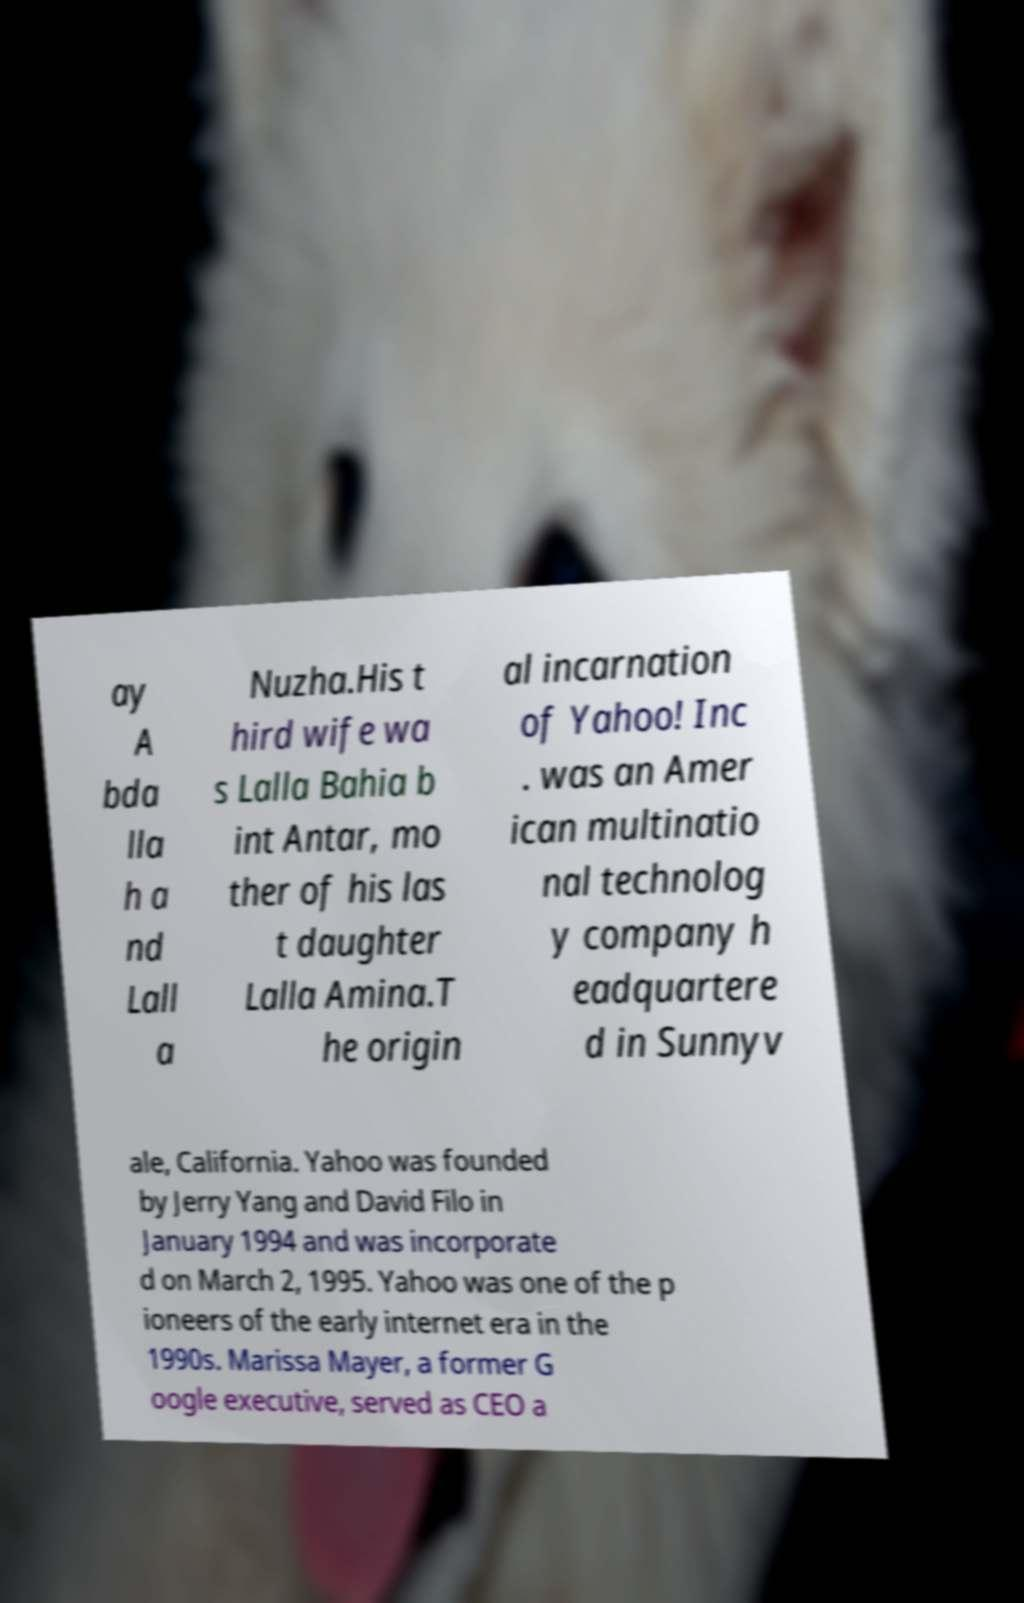Could you extract and type out the text from this image? ay A bda lla h a nd Lall a Nuzha.His t hird wife wa s Lalla Bahia b int Antar, mo ther of his las t daughter Lalla Amina.T he origin al incarnation of Yahoo! Inc . was an Amer ican multinatio nal technolog y company h eadquartere d in Sunnyv ale, California. Yahoo was founded by Jerry Yang and David Filo in January 1994 and was incorporate d on March 2, 1995. Yahoo was one of the p ioneers of the early internet era in the 1990s. Marissa Mayer, a former G oogle executive, served as CEO a 